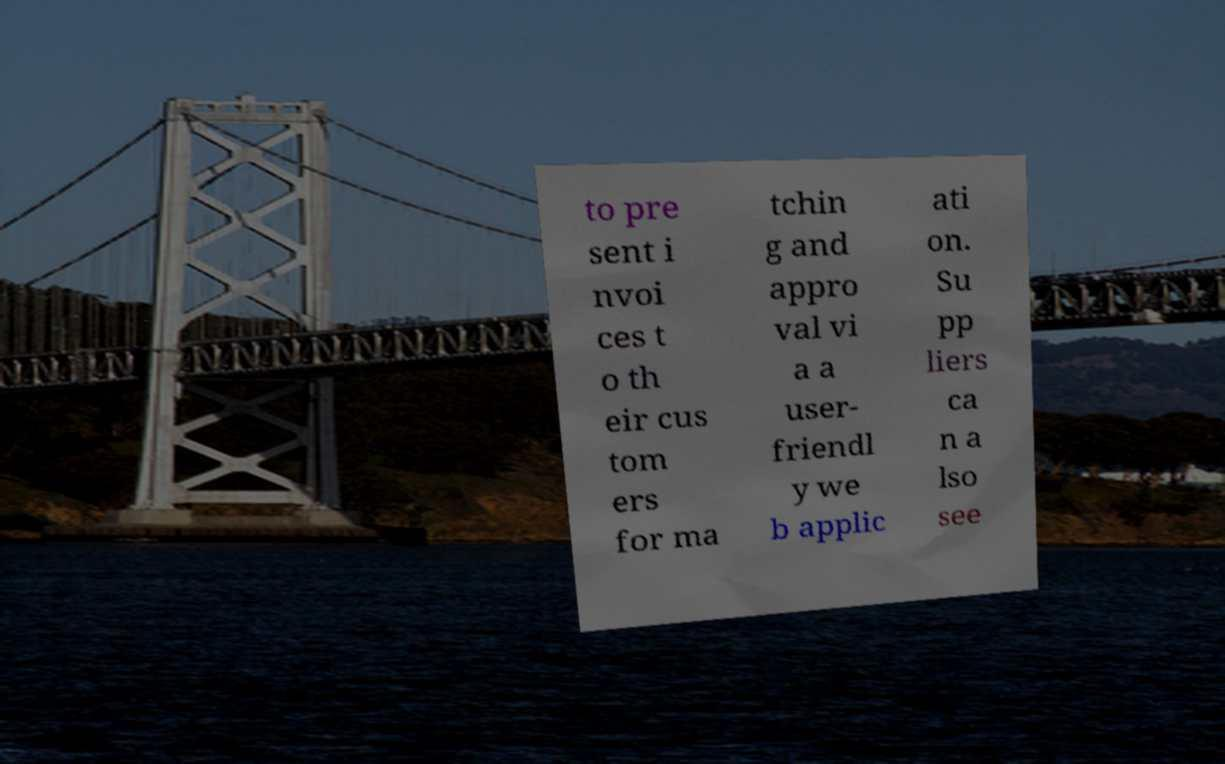Can you accurately transcribe the text from the provided image for me? to pre sent i nvoi ces t o th eir cus tom ers for ma tchin g and appro val vi a a user- friendl y we b applic ati on. Su pp liers ca n a lso see 